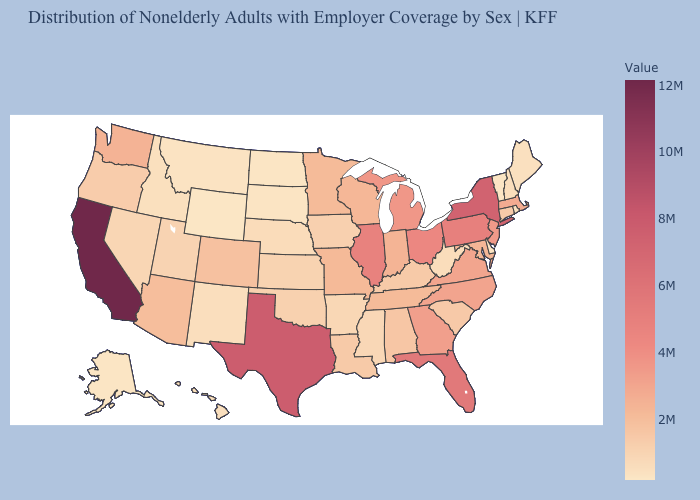Does California have the highest value in the USA?
Be succinct. Yes. Which states hav the highest value in the Northeast?
Keep it brief. New York. Among the states that border California , does Nevada have the lowest value?
Short answer required. Yes. Does Indiana have a higher value than Idaho?
Answer briefly. Yes. 